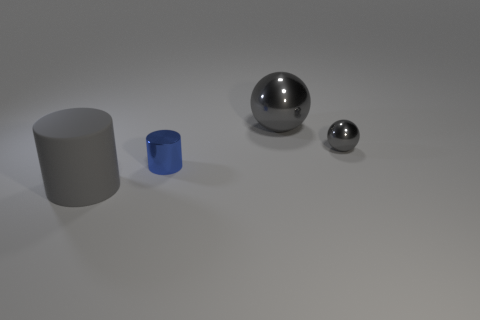Add 1 large metallic objects. How many objects exist? 5 Add 2 yellow balls. How many yellow balls exist? 2 Subtract 0 cyan cubes. How many objects are left? 4 Subtract all shiny spheres. Subtract all gray matte cylinders. How many objects are left? 1 Add 1 big gray rubber things. How many big gray rubber things are left? 2 